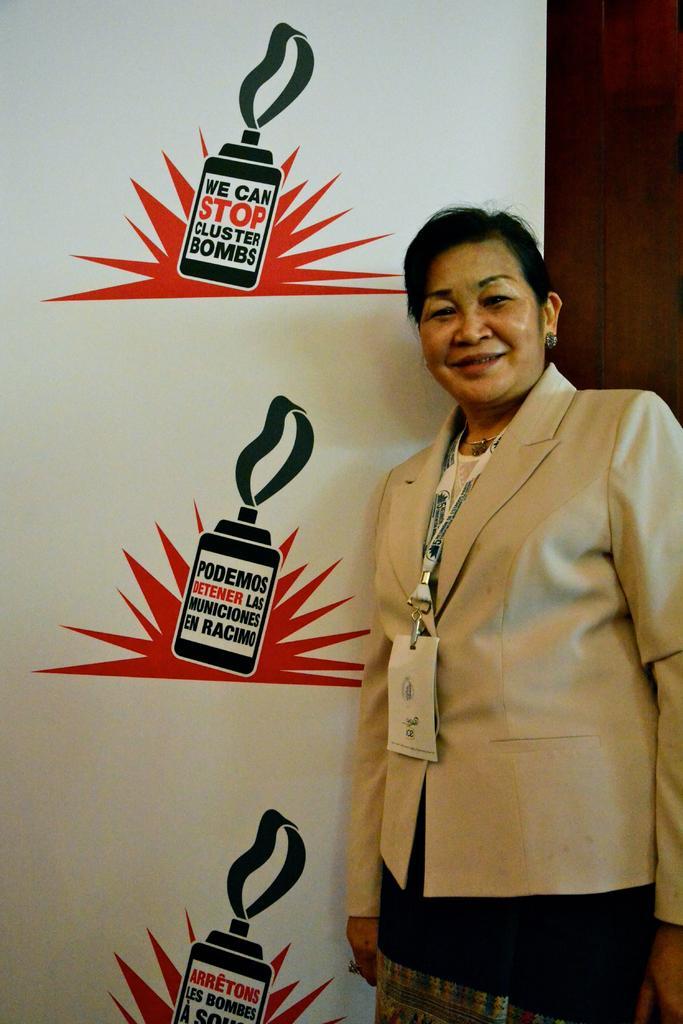How would you summarize this image in a sentence or two? In this picture there is a woman standing and smiling. At the back there is a board and there is text on the board and there is a wooden wall. 